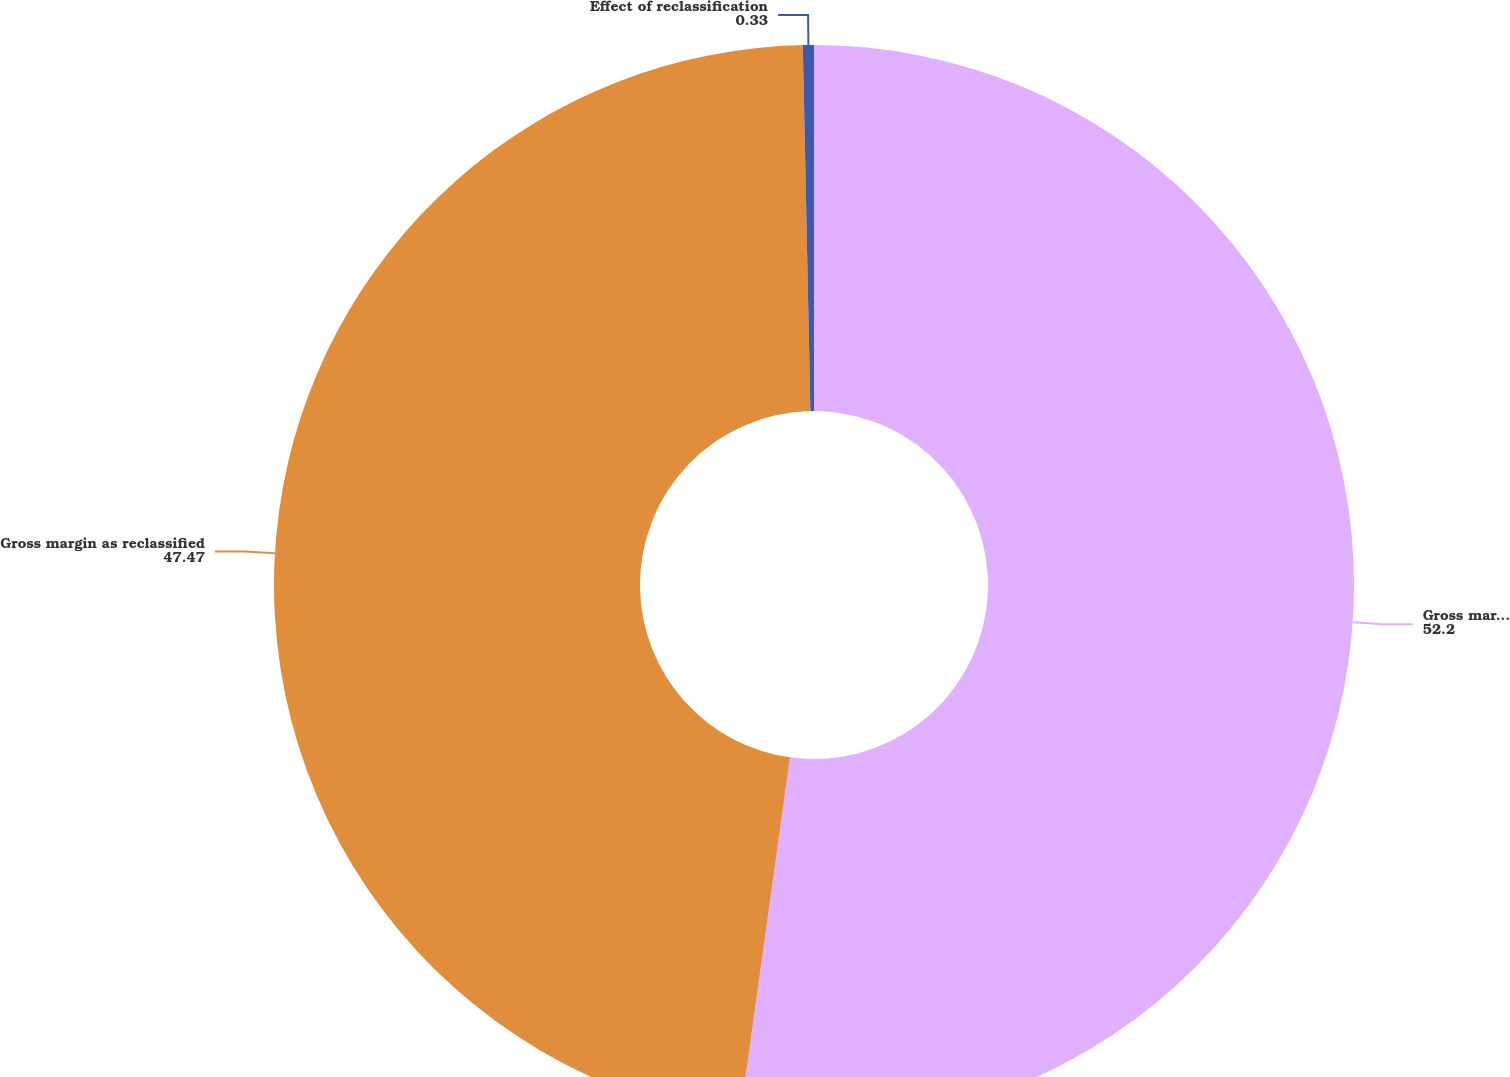<chart> <loc_0><loc_0><loc_500><loc_500><pie_chart><fcel>Gross margin as previously<fcel>Gross margin as reclassified<fcel>Effect of reclassification<nl><fcel>52.2%<fcel>47.47%<fcel>0.33%<nl></chart> 